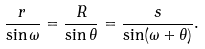Convert formula to latex. <formula><loc_0><loc_0><loc_500><loc_500>\frac { r } { \sin \omega } = \frac { R } { \sin \theta } = \frac { s } { \sin ( \omega + \theta ) } .</formula> 